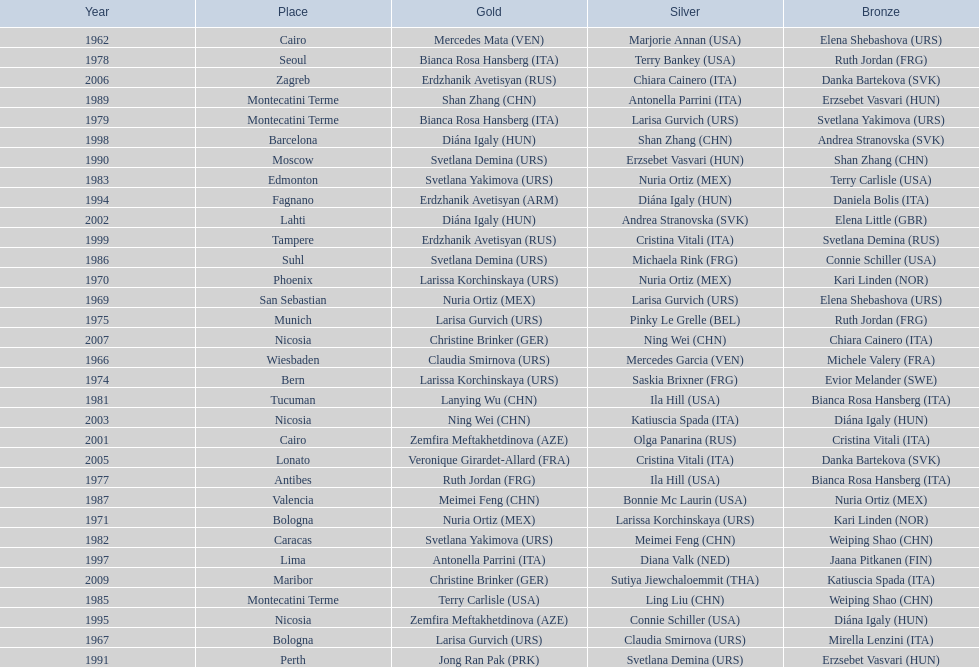What is the total amount of winnings for the united states in gold, silver and bronze? 9. 